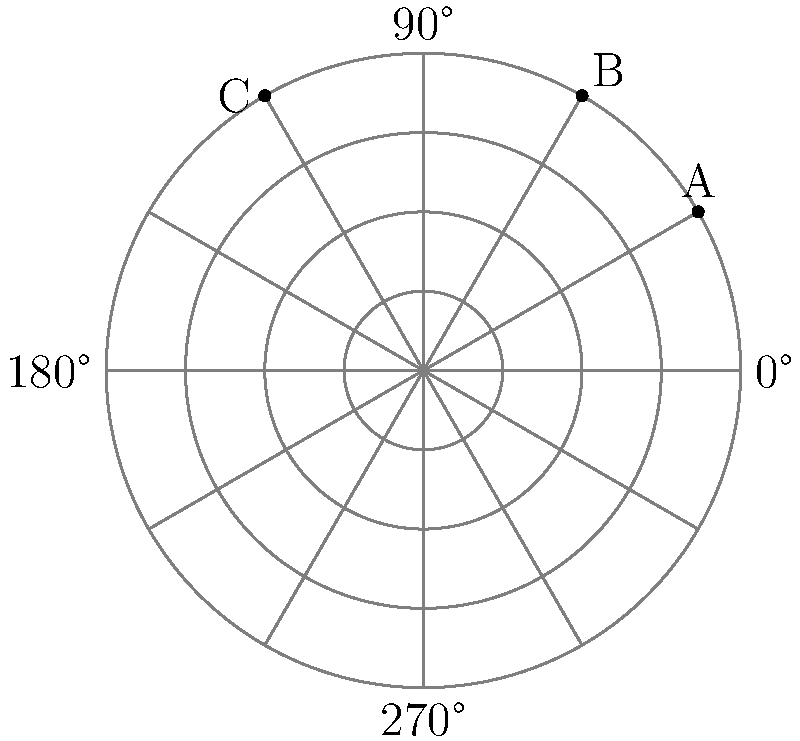Your robot companion is helping you practice reaching different positions during therapy. On the polar grid shown, three goal positions are marked as A, B, and C. If the distance from the center to each circle represents 1 foot, what are the polar coordinates $(r, \theta)$ for position C? Let's approach this step-by-step:

1) First, we need to understand how to read polar coordinates:
   - $r$ is the distance from the center
   - $\theta$ is the angle from the positive x-axis (0°), measured counterclockwise

2) Looking at point C:
   - It's on the outermost circle, which represents 5 feet (as there are 5 circles in total)
   - So, $r = 5$ feet

3) For the angle $\theta$:
   - We can see that C is between 180° and 270°
   - More precisely, it's at the 240° mark (2/3 of the way from 180° to 270°)
   - 240° in radians is $\frac{4\pi}{3}$ (as $180° = \pi$ radians)

4) Therefore, the polar coordinates for C are $(5, \frac{4\pi}{3})$

5) However, it's common to express the angle in degrees for easier understanding, especially for young children

Thus, the final answer is $(5, 240°)$
Answer: $(5, 240°)$ 